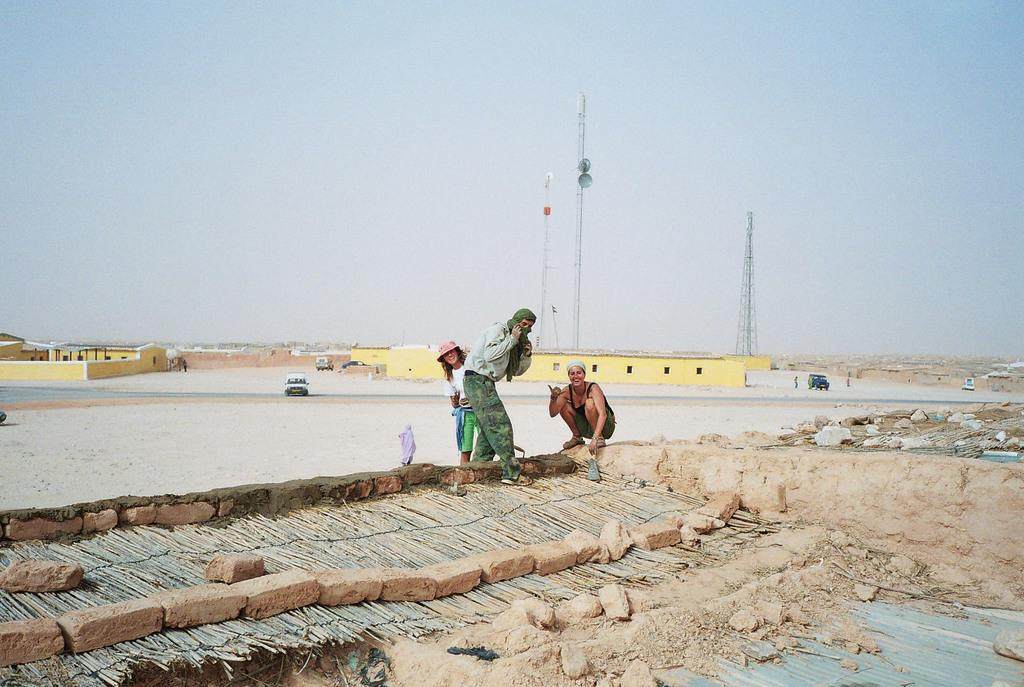How many people are present in the image? There are three people in the image. What can be seen in the image besides the people? There are bricks visible in the image. What is visible in the background of the image? There are vehicles, towers, and houses in the background of the image. What type of birds can be seen flying over the map in the image? There is no map present in the image, and therefore no birds can be seen flying over it. 